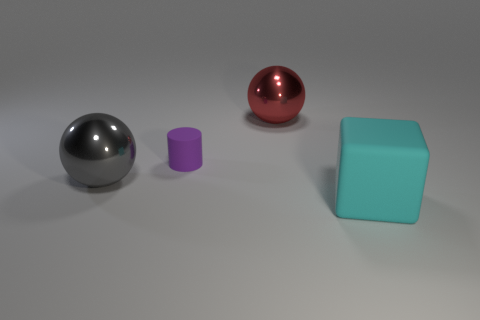Add 2 large matte objects. How many objects exist? 6 Subtract all cubes. How many objects are left? 3 Subtract 0 blue spheres. How many objects are left? 4 Subtract all matte things. Subtract all small matte objects. How many objects are left? 1 Add 1 big objects. How many big objects are left? 4 Add 4 cyan matte things. How many cyan matte things exist? 5 